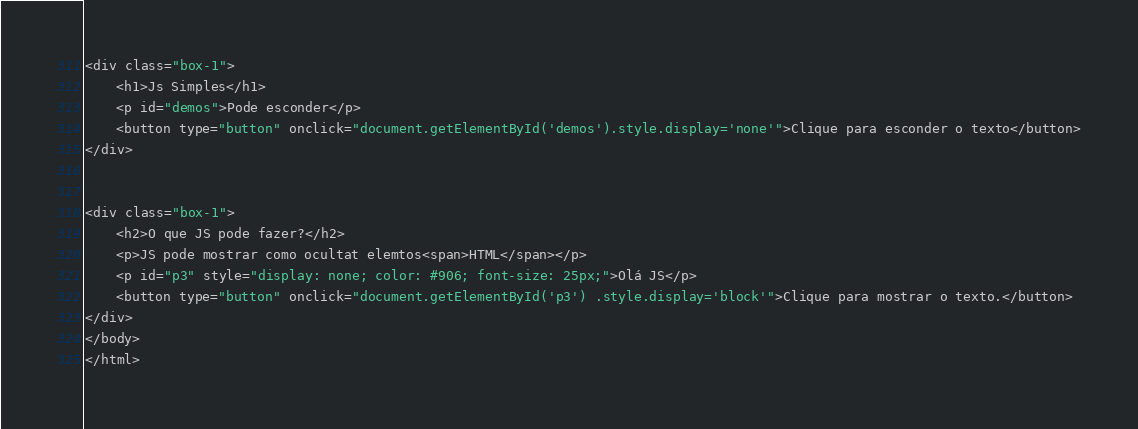<code> <loc_0><loc_0><loc_500><loc_500><_HTML_>
<div class="box-1">
	<h1>Js Simples</h1>
	<p id="demos">Pode esconder</p>
	<button type="button" onclick="document.getElementById('demos').style.display='none'">Clique para esconder o texto</button>
</div>


<div class="box-1">
	<h2>O que JS pode fazer?</h2>
	<p>JS pode mostrar como ocultat elemtos<span>HTML</span></p>
	<p id="p3" style="display: none; color: #906; font-size: 25px;">Olá JS</p>
	<button type="button" onclick="document.getElementById('p3') .style.display='block'">Clique para mostrar o texto.</button>
</div>
</body>
</html></code> 